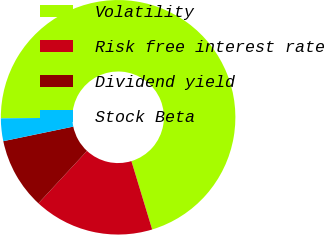<chart> <loc_0><loc_0><loc_500><loc_500><pie_chart><fcel>Volatility<fcel>Risk free interest rate<fcel>Dividend yield<fcel>Stock Beta<nl><fcel>70.46%<fcel>16.58%<fcel>9.85%<fcel>3.12%<nl></chart> 